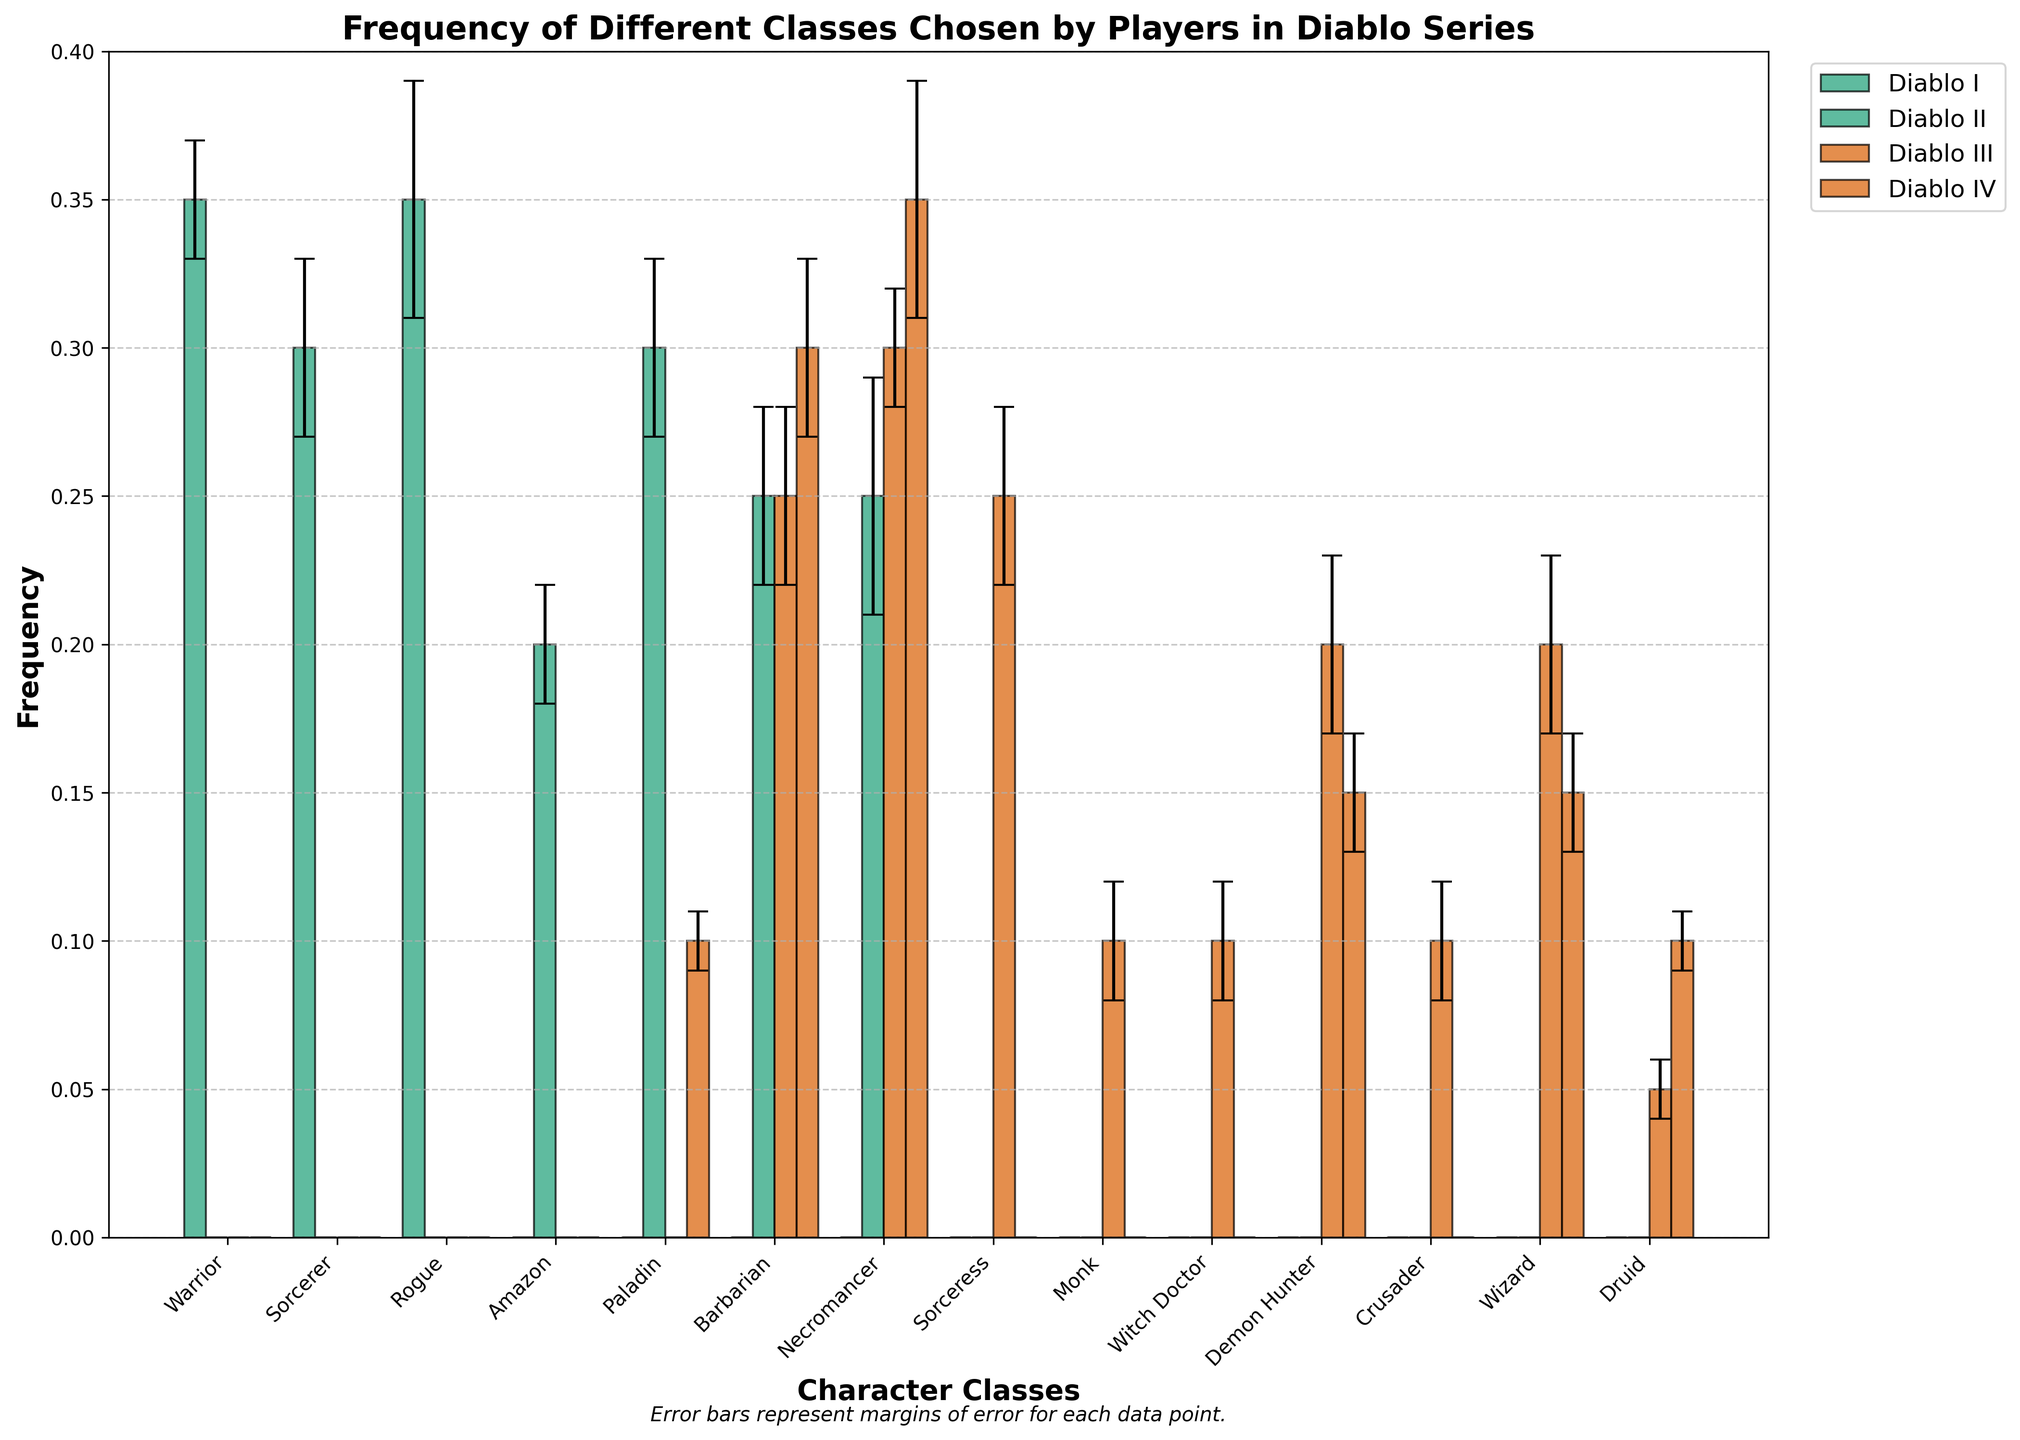What's the title of the chart? The title is located at the top of the chart and typically summarizes the main idea or purpose.
Answer: Frequency of Different Classes Chosen by Players in Diablo Series Which character class has the highest frequency in Diablo IV? Look at the height of the bars for Diablo IV. The class with the highest bar represents the highest frequency.
Answer: Necromancer What's the margin of error for the Barbarian class in Diablo III? Identify the error bars for Barbarian in Diablo III. The size of the error bar indicates the margin of error.
Answer: 0.03 How many different character classes are depicted in the chart? Count the number of unique character class labels on the x-axis.
Answer: 14 Which game has the most diverse distribution of class frequencies? Look at the spread and variation of the bar heights for each game. More variation indicates a more diverse distribution.
Answer: Diablo III What is the combined frequency of the Sorcerer class in Diablo I and the Paladin class in Diablo II? Add the frequencies of Sorcerer in Diablo I and Paladin in Diablo II.
Answer: 0.30 + 0.30 = 0.60 Is the frequency of the Barbarian class in Diablo II higher or lower than in Diablo IV? Compare the height of the bars for Barbarian in Diablo II and Diablo IV.
Answer: Lower What's the sum of the frequencies of the Necromancer class across all four games? Add the frequencies of Necromancer in Diablo II, Diablo III, and Diablo IV. (Diablo I frequency is 0.00)
Answer: 0.25 + 0.30 + 0.35 = 0.90 Which game features the Amazon class? Identify where the bar for Amazon appears non-zero.
Answer: Diablo II What's the range of the margin of error for the Necromancer class in Diablo IV? Identify the margin of error for Necromancer in Diablo IV. Since margin of error is a single value, the range here is the difference.
Answer: 0.04 